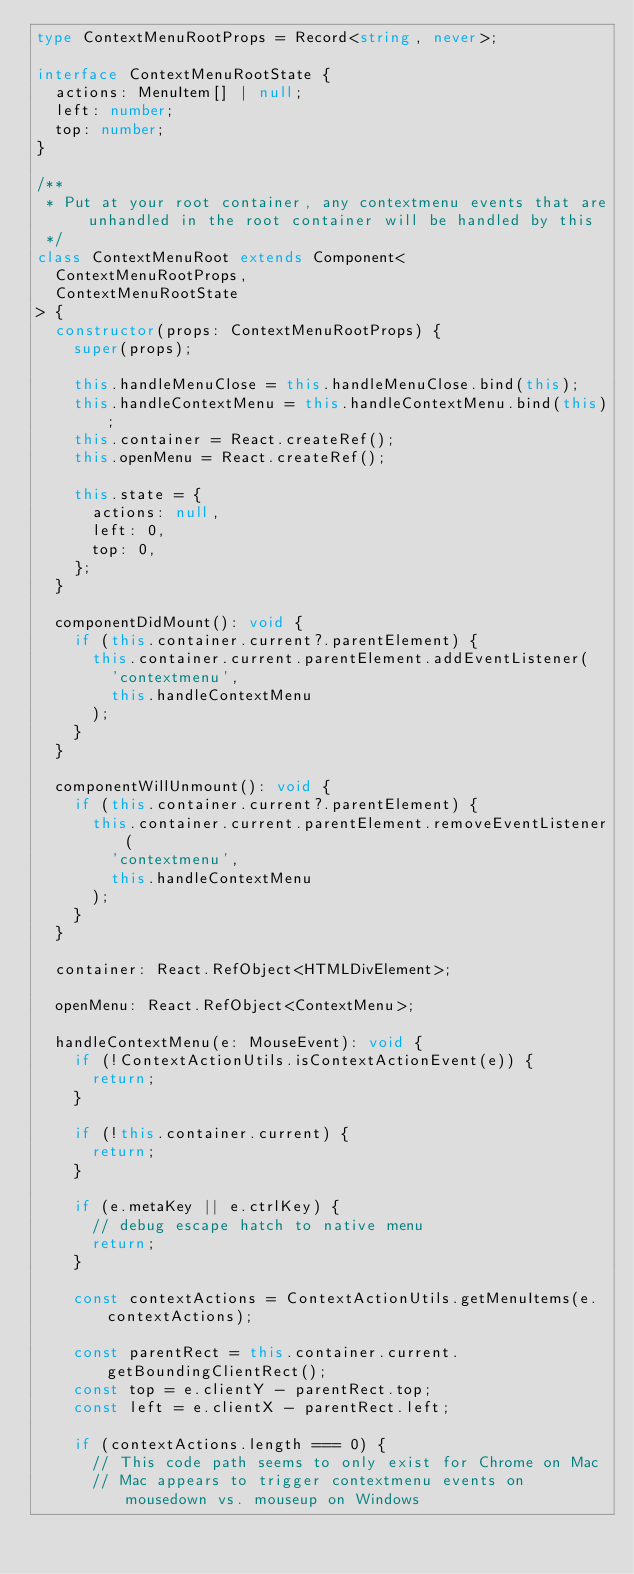Convert code to text. <code><loc_0><loc_0><loc_500><loc_500><_TypeScript_>type ContextMenuRootProps = Record<string, never>;

interface ContextMenuRootState {
  actions: MenuItem[] | null;
  left: number;
  top: number;
}

/**
 * Put at your root container, any contextmenu events that are unhandled in the root container will be handled by this
 */
class ContextMenuRoot extends Component<
  ContextMenuRootProps,
  ContextMenuRootState
> {
  constructor(props: ContextMenuRootProps) {
    super(props);

    this.handleMenuClose = this.handleMenuClose.bind(this);
    this.handleContextMenu = this.handleContextMenu.bind(this);
    this.container = React.createRef();
    this.openMenu = React.createRef();

    this.state = {
      actions: null,
      left: 0,
      top: 0,
    };
  }

  componentDidMount(): void {
    if (this.container.current?.parentElement) {
      this.container.current.parentElement.addEventListener(
        'contextmenu',
        this.handleContextMenu
      );
    }
  }

  componentWillUnmount(): void {
    if (this.container.current?.parentElement) {
      this.container.current.parentElement.removeEventListener(
        'contextmenu',
        this.handleContextMenu
      );
    }
  }

  container: React.RefObject<HTMLDivElement>;

  openMenu: React.RefObject<ContextMenu>;

  handleContextMenu(e: MouseEvent): void {
    if (!ContextActionUtils.isContextActionEvent(e)) {
      return;
    }

    if (!this.container.current) {
      return;
    }

    if (e.metaKey || e.ctrlKey) {
      // debug escape hatch to native menu
      return;
    }

    const contextActions = ContextActionUtils.getMenuItems(e.contextActions);

    const parentRect = this.container.current.getBoundingClientRect();
    const top = e.clientY - parentRect.top;
    const left = e.clientX - parentRect.left;

    if (contextActions.length === 0) {
      // This code path seems to only exist for Chrome on Mac
      // Mac appears to trigger contextmenu events on mousedown vs. mouseup on Windows</code> 